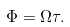Convert formula to latex. <formula><loc_0><loc_0><loc_500><loc_500>\Phi = \Omega \tau .</formula> 